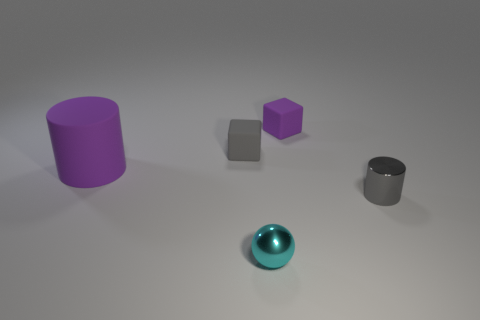How does the lighting in the image affect the appearance of the objects? The lighting in the image creates soft shadows and subtle reflections, which gives the objects a three-dimensional appearance and highlights their matte and shiny surfaces. It also contributes to the overall mood by providing a tranquil and neutral setting. 